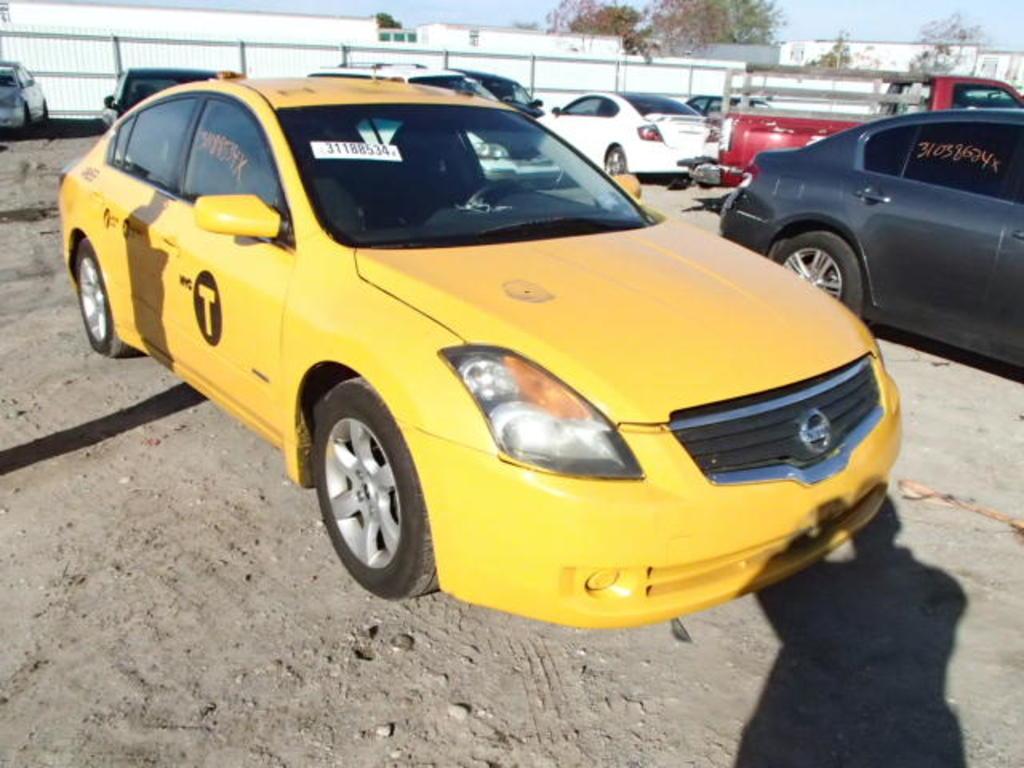What is the inventory number on the yellow car?
Give a very brief answer. 31188534. What are the words before the big letter t on the side of the yellow car?
Make the answer very short. Nyc. 